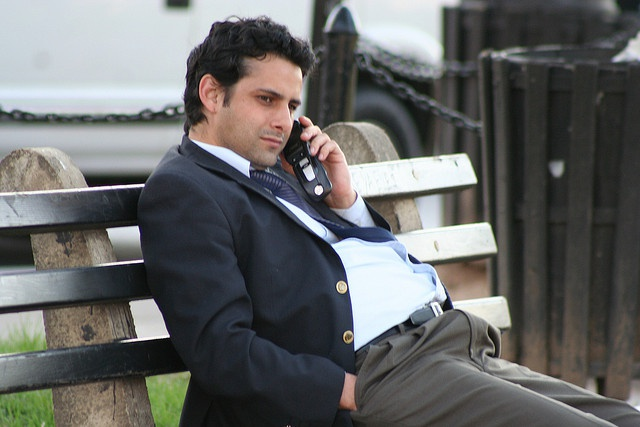Describe the objects in this image and their specific colors. I can see people in lightgray, black, gray, and white tones, bench in lightgray, black, gray, and darkgray tones, car in lightgray, darkgray, black, and gray tones, tie in lightgray, navy, gray, darkblue, and black tones, and cell phone in lightgray, black, gray, and darkgray tones in this image. 